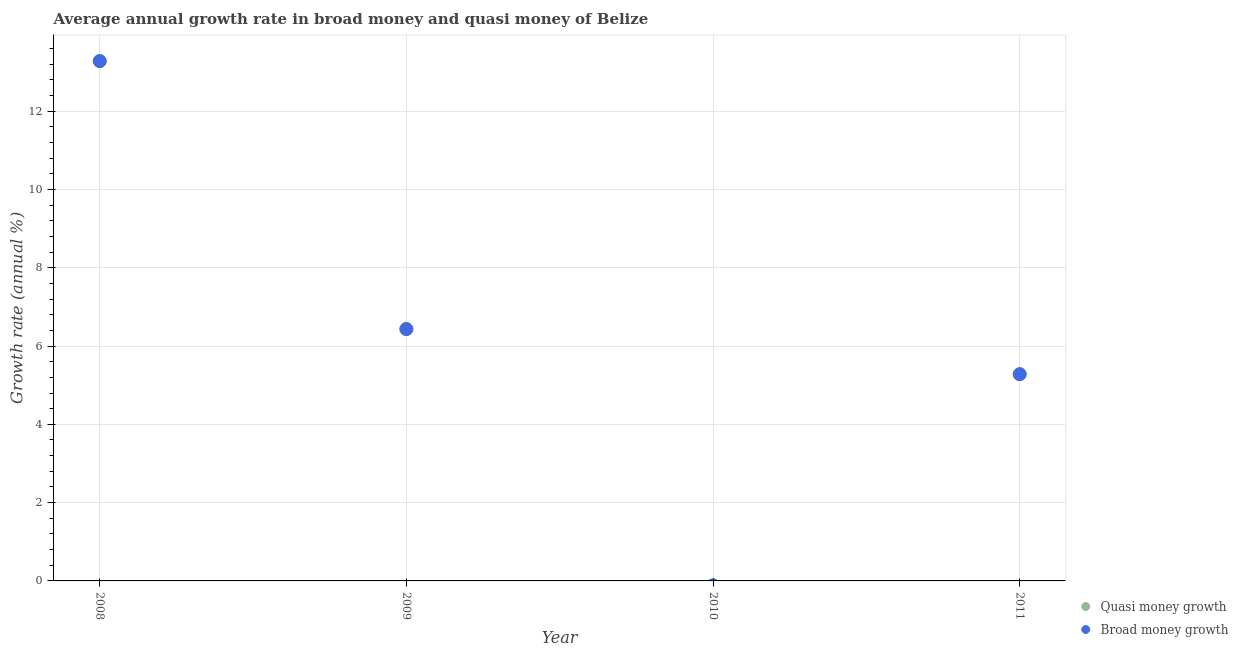How many different coloured dotlines are there?
Keep it short and to the point. 2. What is the annual growth rate in broad money in 2008?
Offer a very short reply. 13.28. Across all years, what is the maximum annual growth rate in broad money?
Offer a very short reply. 13.28. Across all years, what is the minimum annual growth rate in broad money?
Give a very brief answer. 0. In which year was the annual growth rate in broad money maximum?
Your answer should be very brief. 2008. What is the total annual growth rate in quasi money in the graph?
Provide a short and direct response. 24.99. What is the difference between the annual growth rate in broad money in 2009 and that in 2011?
Keep it short and to the point. 1.15. What is the difference between the annual growth rate in quasi money in 2009 and the annual growth rate in broad money in 2008?
Your answer should be compact. -6.84. What is the average annual growth rate in broad money per year?
Make the answer very short. 6.25. What is the ratio of the annual growth rate in broad money in 2008 to that in 2011?
Offer a very short reply. 2.51. Is the difference between the annual growth rate in quasi money in 2008 and 2009 greater than the difference between the annual growth rate in broad money in 2008 and 2009?
Give a very brief answer. No. What is the difference between the highest and the second highest annual growth rate in broad money?
Your response must be concise. 6.84. What is the difference between the highest and the lowest annual growth rate in quasi money?
Give a very brief answer. 13.28. Is the sum of the annual growth rate in quasi money in 2009 and 2011 greater than the maximum annual growth rate in broad money across all years?
Provide a succinct answer. No. Is the annual growth rate in broad money strictly greater than the annual growth rate in quasi money over the years?
Give a very brief answer. No. Is the annual growth rate in quasi money strictly less than the annual growth rate in broad money over the years?
Your answer should be compact. No. How many years are there in the graph?
Make the answer very short. 4. What is the difference between two consecutive major ticks on the Y-axis?
Keep it short and to the point. 2. Are the values on the major ticks of Y-axis written in scientific E-notation?
Offer a very short reply. No. Does the graph contain any zero values?
Offer a terse response. Yes. How are the legend labels stacked?
Give a very brief answer. Vertical. What is the title of the graph?
Ensure brevity in your answer.  Average annual growth rate in broad money and quasi money of Belize. Does "2012 US$" appear as one of the legend labels in the graph?
Your response must be concise. No. What is the label or title of the X-axis?
Offer a terse response. Year. What is the label or title of the Y-axis?
Offer a very short reply. Growth rate (annual %). What is the Growth rate (annual %) of Quasi money growth in 2008?
Keep it short and to the point. 13.28. What is the Growth rate (annual %) in Broad money growth in 2008?
Provide a succinct answer. 13.28. What is the Growth rate (annual %) in Quasi money growth in 2009?
Your answer should be very brief. 6.43. What is the Growth rate (annual %) in Broad money growth in 2009?
Provide a succinct answer. 6.43. What is the Growth rate (annual %) in Quasi money growth in 2011?
Your answer should be compact. 5.28. What is the Growth rate (annual %) of Broad money growth in 2011?
Give a very brief answer. 5.28. Across all years, what is the maximum Growth rate (annual %) of Quasi money growth?
Give a very brief answer. 13.28. Across all years, what is the maximum Growth rate (annual %) in Broad money growth?
Keep it short and to the point. 13.28. Across all years, what is the minimum Growth rate (annual %) in Broad money growth?
Offer a terse response. 0. What is the total Growth rate (annual %) in Quasi money growth in the graph?
Offer a very short reply. 24.99. What is the total Growth rate (annual %) of Broad money growth in the graph?
Keep it short and to the point. 24.99. What is the difference between the Growth rate (annual %) of Quasi money growth in 2008 and that in 2009?
Your answer should be very brief. 6.84. What is the difference between the Growth rate (annual %) in Broad money growth in 2008 and that in 2009?
Keep it short and to the point. 6.84. What is the difference between the Growth rate (annual %) of Quasi money growth in 2008 and that in 2011?
Offer a very short reply. 8. What is the difference between the Growth rate (annual %) in Broad money growth in 2008 and that in 2011?
Keep it short and to the point. 8. What is the difference between the Growth rate (annual %) of Quasi money growth in 2009 and that in 2011?
Make the answer very short. 1.15. What is the difference between the Growth rate (annual %) of Broad money growth in 2009 and that in 2011?
Provide a short and direct response. 1.15. What is the difference between the Growth rate (annual %) in Quasi money growth in 2008 and the Growth rate (annual %) in Broad money growth in 2009?
Ensure brevity in your answer.  6.84. What is the difference between the Growth rate (annual %) of Quasi money growth in 2008 and the Growth rate (annual %) of Broad money growth in 2011?
Your answer should be very brief. 8. What is the difference between the Growth rate (annual %) in Quasi money growth in 2009 and the Growth rate (annual %) in Broad money growth in 2011?
Offer a terse response. 1.15. What is the average Growth rate (annual %) of Quasi money growth per year?
Make the answer very short. 6.25. What is the average Growth rate (annual %) in Broad money growth per year?
Keep it short and to the point. 6.25. In the year 2008, what is the difference between the Growth rate (annual %) of Quasi money growth and Growth rate (annual %) of Broad money growth?
Keep it short and to the point. 0. In the year 2009, what is the difference between the Growth rate (annual %) in Quasi money growth and Growth rate (annual %) in Broad money growth?
Give a very brief answer. 0. What is the ratio of the Growth rate (annual %) in Quasi money growth in 2008 to that in 2009?
Ensure brevity in your answer.  2.06. What is the ratio of the Growth rate (annual %) of Broad money growth in 2008 to that in 2009?
Give a very brief answer. 2.06. What is the ratio of the Growth rate (annual %) in Quasi money growth in 2008 to that in 2011?
Provide a short and direct response. 2.51. What is the ratio of the Growth rate (annual %) of Broad money growth in 2008 to that in 2011?
Your answer should be very brief. 2.51. What is the ratio of the Growth rate (annual %) of Quasi money growth in 2009 to that in 2011?
Your answer should be compact. 1.22. What is the ratio of the Growth rate (annual %) of Broad money growth in 2009 to that in 2011?
Provide a short and direct response. 1.22. What is the difference between the highest and the second highest Growth rate (annual %) of Quasi money growth?
Ensure brevity in your answer.  6.84. What is the difference between the highest and the second highest Growth rate (annual %) in Broad money growth?
Your response must be concise. 6.84. What is the difference between the highest and the lowest Growth rate (annual %) of Quasi money growth?
Your response must be concise. 13.28. What is the difference between the highest and the lowest Growth rate (annual %) of Broad money growth?
Your answer should be compact. 13.28. 